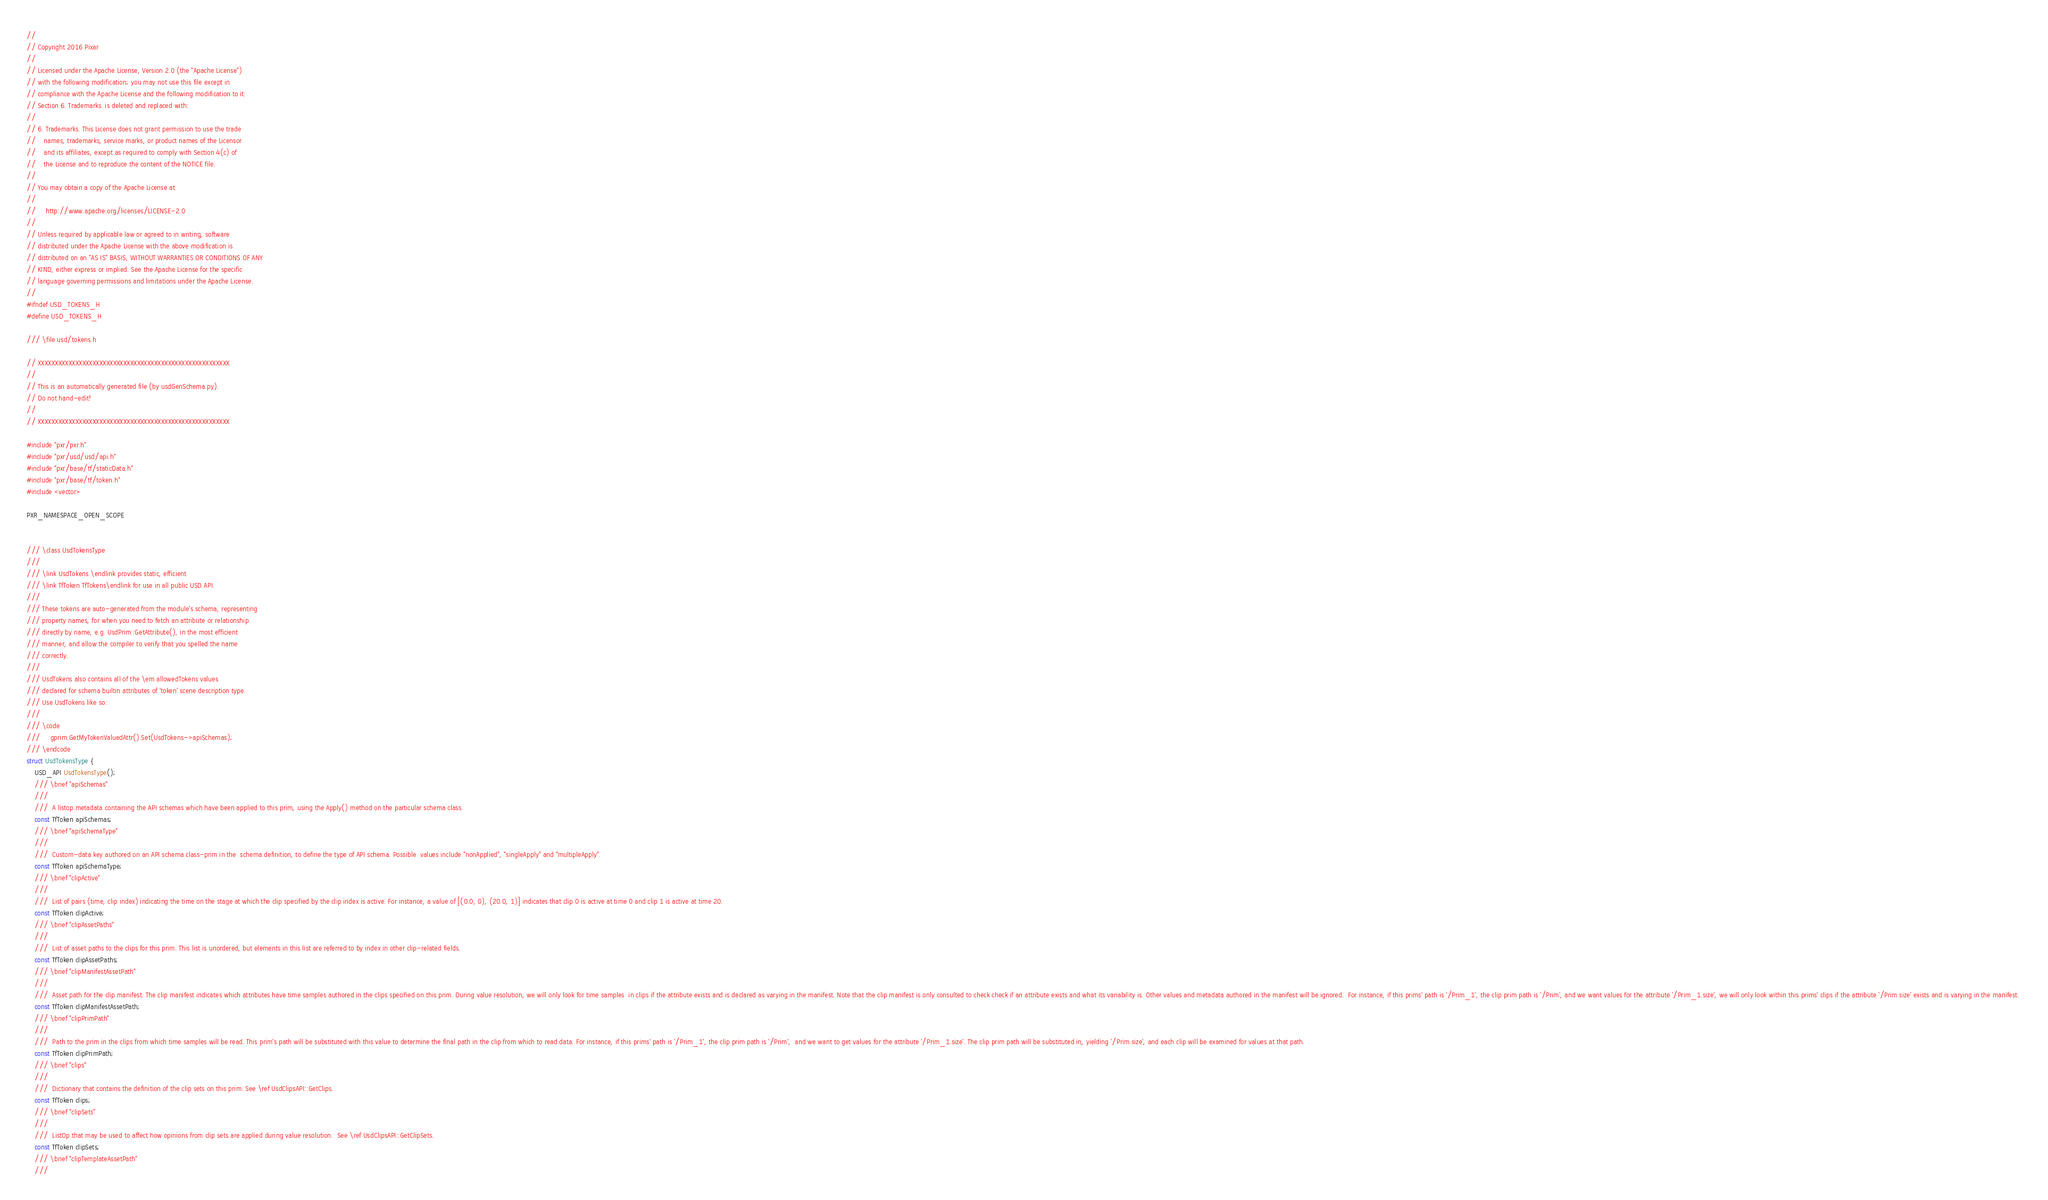<code> <loc_0><loc_0><loc_500><loc_500><_C_>//
// Copyright 2016 Pixar
//
// Licensed under the Apache License, Version 2.0 (the "Apache License")
// with the following modification; you may not use this file except in
// compliance with the Apache License and the following modification to it:
// Section 6. Trademarks. is deleted and replaced with:
//
// 6. Trademarks. This License does not grant permission to use the trade
//    names, trademarks, service marks, or product names of the Licensor
//    and its affiliates, except as required to comply with Section 4(c) of
//    the License and to reproduce the content of the NOTICE file.
//
// You may obtain a copy of the Apache License at
//
//     http://www.apache.org/licenses/LICENSE-2.0
//
// Unless required by applicable law or agreed to in writing, software
// distributed under the Apache License with the above modification is
// distributed on an "AS IS" BASIS, WITHOUT WARRANTIES OR CONDITIONS OF ANY
// KIND, either express or implied. See the Apache License for the specific
// language governing permissions and limitations under the Apache License.
//
#ifndef USD_TOKENS_H
#define USD_TOKENS_H

/// \file usd/tokens.h

// XXXXXXXXXXXXXXXXXXXXXXXXXXXXXXXXXXXXXXXXXXXXXXXXXXXXXXXX
// 
// This is an automatically generated file (by usdGenSchema.py).
// Do not hand-edit!
// 
// XXXXXXXXXXXXXXXXXXXXXXXXXXXXXXXXXXXXXXXXXXXXXXXXXXXXXXXX

#include "pxr/pxr.h"
#include "pxr/usd/usd/api.h"
#include "pxr/base/tf/staticData.h"
#include "pxr/base/tf/token.h"
#include <vector>

PXR_NAMESPACE_OPEN_SCOPE


/// \class UsdTokensType
///
/// \link UsdTokens \endlink provides static, efficient
/// \link TfToken TfTokens\endlink for use in all public USD API.
///
/// These tokens are auto-generated from the module's schema, representing
/// property names, for when you need to fetch an attribute or relationship
/// directly by name, e.g. UsdPrim::GetAttribute(), in the most efficient
/// manner, and allow the compiler to verify that you spelled the name
/// correctly.
///
/// UsdTokens also contains all of the \em allowedTokens values
/// declared for schema builtin attributes of 'token' scene description type.
/// Use UsdTokens like so:
///
/// \code
///     gprim.GetMyTokenValuedAttr().Set(UsdTokens->apiSchemas);
/// \endcode
struct UsdTokensType {
    USD_API UsdTokensType();
    /// \brief "apiSchemas"
    /// 
    ///  A listop metadata containing the API schemas which have been applied to this prim, using the Apply() method on the particular schema class.  
    const TfToken apiSchemas;
    /// \brief "apiSchemaType"
    /// 
    ///  Custom-data key authored on an API schema class-prim in the  schema definition, to define the type of API schema. Possible  values include "nonApplied", "singleApply" and "multipleApply".  
    const TfToken apiSchemaType;
    /// \brief "clipActive"
    /// 
    ///  List of pairs (time, clip index) indicating the time on the stage at which the clip specified by the clip index is active. For instance, a value of [(0.0, 0), (20.0, 1)] indicates that clip 0 is active at time 0 and clip 1 is active at time 20. 
    const TfToken clipActive;
    /// \brief "clipAssetPaths"
    /// 
    ///  List of asset paths to the clips for this prim. This list is unordered, but elements in this list are referred to by index in other clip-related fields. 
    const TfToken clipAssetPaths;
    /// \brief "clipManifestAssetPath"
    /// 
    ///  Asset path for the clip manifest. The clip manifest indicates which attributes have time samples authored in the clips specified on this prim. During value resolution, we will only look for time samples  in clips if the attribute exists and is declared as varying in the manifest. Note that the clip manifest is only consulted to check check if an attribute exists and what its variability is. Other values and metadata authored in the manifest will be ignored.  For instance, if this prims' path is '/Prim_1', the clip prim path is '/Prim', and we want values for the attribute '/Prim_1.size', we will only look within this prims' clips if the attribute '/Prim.size' exists and is varying in the manifest. 
    const TfToken clipManifestAssetPath;
    /// \brief "clipPrimPath"
    /// 
    ///  Path to the prim in the clips from which time samples will be read. This prim's path will be substituted with this value to determine the final path in the clip from which to read data. For instance, if this prims' path is '/Prim_1', the clip prim path is '/Prim',  and we want to get values for the attribute '/Prim_1.size'. The clip prim path will be substituted in, yielding '/Prim.size', and each clip will be examined for values at that path. 
    const TfToken clipPrimPath;
    /// \brief "clips"
    /// 
    ///  Dictionary that contains the definition of the clip sets on this prim. See \ref UsdClipsAPI::GetClips. 
    const TfToken clips;
    /// \brief "clipSets"
    /// 
    ///  ListOp that may be used to affect how opinions from clip sets are applied during value resolution.  See \ref UsdClipsAPI::GetClipSets. 
    const TfToken clipSets;
    /// \brief "clipTemplateAssetPath"
    /// </code> 